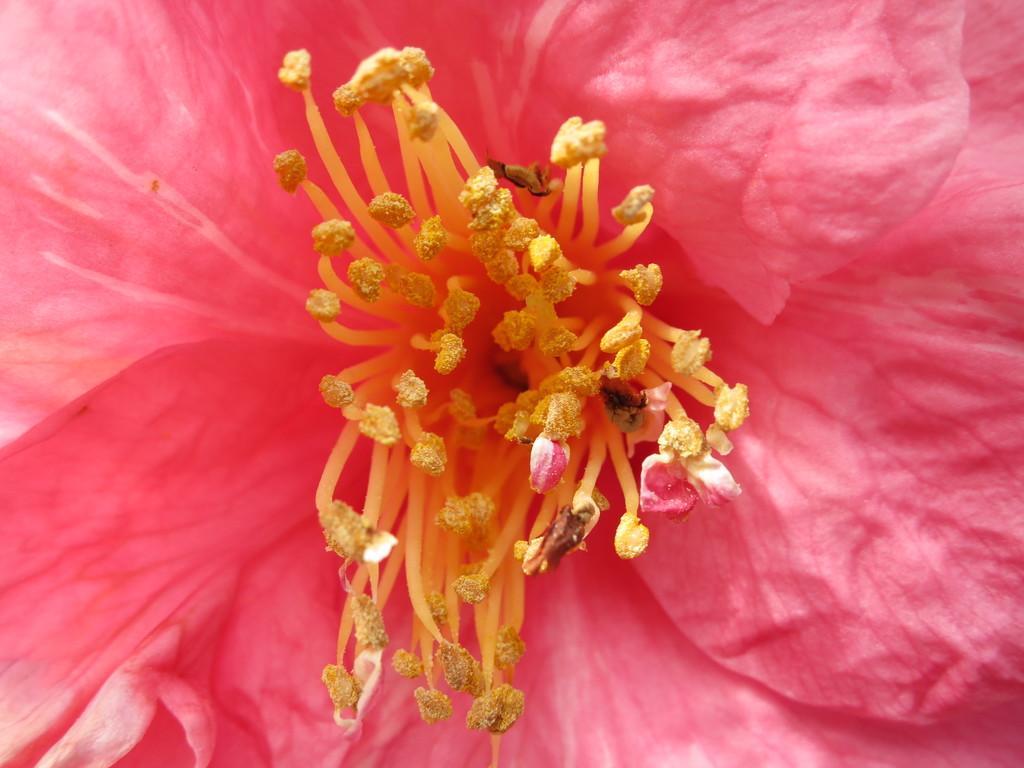Describe this image in one or two sentences. In the image there is a pink flower with stigma in the middle. 